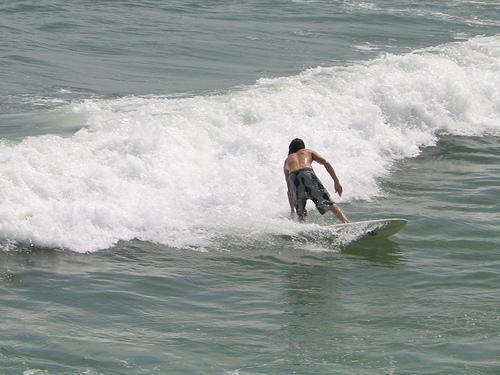How many people are in this picture?
Give a very brief answer. 1. How many surfboards are there?
Give a very brief answer. 1. How many of the buses visible on the street are two story?
Give a very brief answer. 0. 